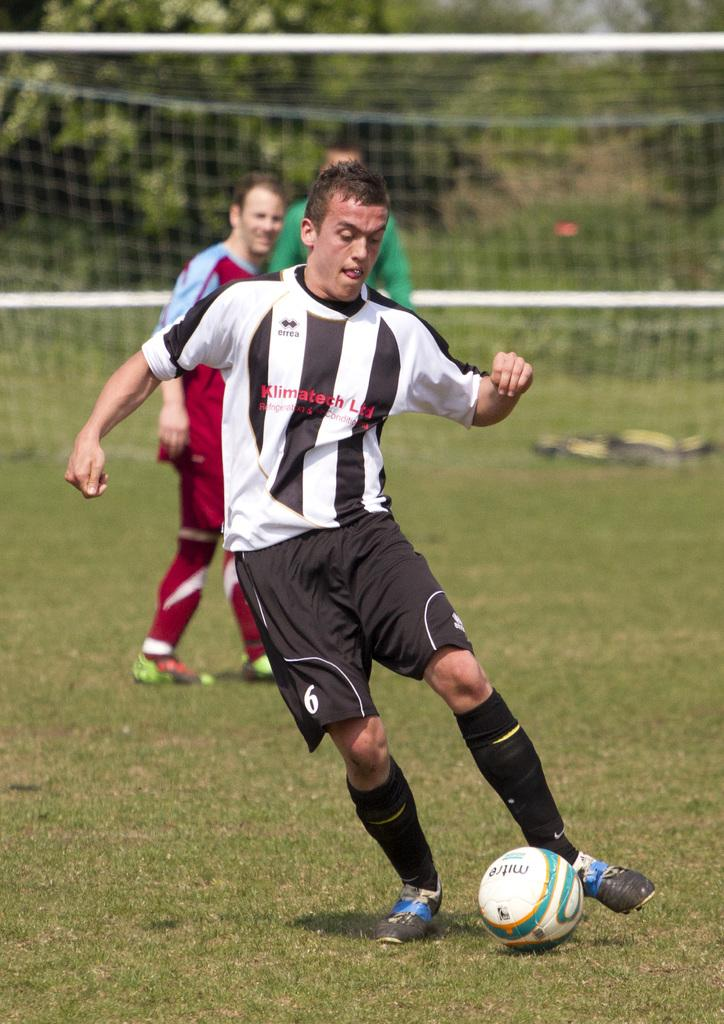What is the man in the image doing? The man is running on the ground. What is in front of the man? There is a ball in front of the man. Are there any other people in the image? Yes, there are two people standing nearby. What is located at the back of the scene? There is a net at the back of the scene. What natural element can be seen in the image? There is a tree visible in the image. What type of paper is the doctor holding while examining the car in the image? There is no doctor, car, or paper present in the image. 